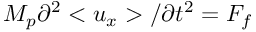<formula> <loc_0><loc_0><loc_500><loc_500>M _ { p } \partial ^ { 2 } < u _ { x } > / \partial t ^ { 2 } = F _ { f }</formula> 